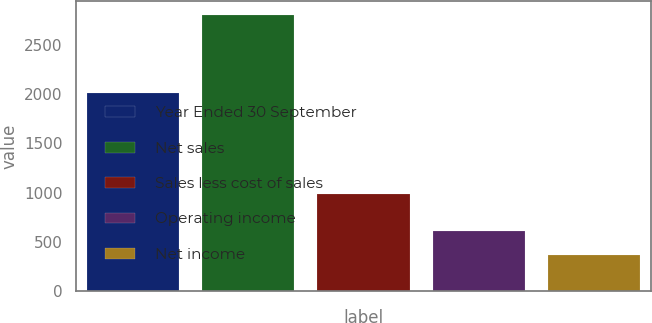Convert chart. <chart><loc_0><loc_0><loc_500><loc_500><bar_chart><fcel>Year Ended 30 September<fcel>Net sales<fcel>Sales less cost of sales<fcel>Operating income<fcel>Net income<nl><fcel>2014<fcel>2808.7<fcel>984.7<fcel>604.42<fcel>359.5<nl></chart> 